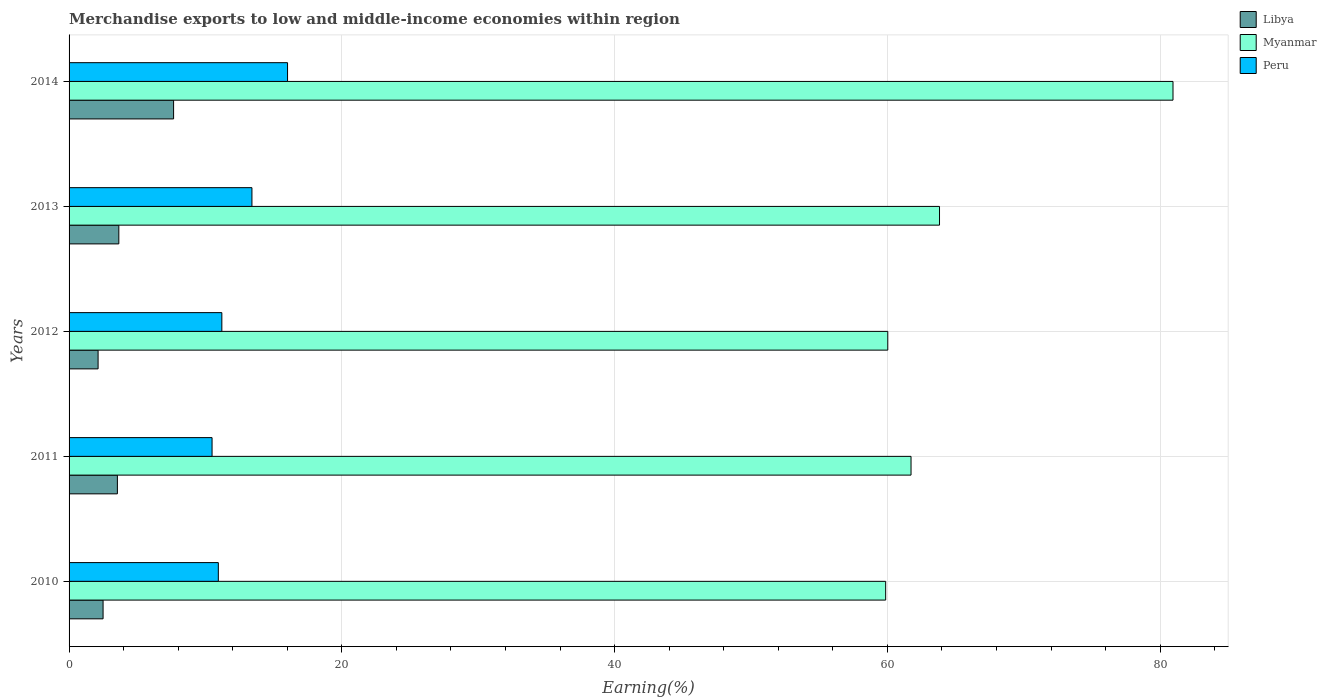How many different coloured bars are there?
Offer a very short reply. 3. How many groups of bars are there?
Offer a very short reply. 5. How many bars are there on the 3rd tick from the top?
Offer a very short reply. 3. How many bars are there on the 1st tick from the bottom?
Offer a very short reply. 3. What is the label of the 4th group of bars from the top?
Your answer should be very brief. 2011. In how many cases, is the number of bars for a given year not equal to the number of legend labels?
Your answer should be very brief. 0. What is the percentage of amount earned from merchandise exports in Libya in 2011?
Make the answer very short. 3.54. Across all years, what is the maximum percentage of amount earned from merchandise exports in Myanmar?
Make the answer very short. 80.94. Across all years, what is the minimum percentage of amount earned from merchandise exports in Peru?
Provide a succinct answer. 10.48. What is the total percentage of amount earned from merchandise exports in Peru in the graph?
Your answer should be compact. 62.06. What is the difference between the percentage of amount earned from merchandise exports in Libya in 2013 and that in 2014?
Offer a terse response. -4.02. What is the difference between the percentage of amount earned from merchandise exports in Myanmar in 2011 and the percentage of amount earned from merchandise exports in Libya in 2014?
Your response must be concise. 54.07. What is the average percentage of amount earned from merchandise exports in Libya per year?
Provide a succinct answer. 3.9. In the year 2012, what is the difference between the percentage of amount earned from merchandise exports in Libya and percentage of amount earned from merchandise exports in Peru?
Provide a succinct answer. -9.07. What is the ratio of the percentage of amount earned from merchandise exports in Libya in 2013 to that in 2014?
Make the answer very short. 0.48. Is the percentage of amount earned from merchandise exports in Libya in 2012 less than that in 2014?
Keep it short and to the point. Yes. Is the difference between the percentage of amount earned from merchandise exports in Libya in 2010 and 2014 greater than the difference between the percentage of amount earned from merchandise exports in Peru in 2010 and 2014?
Ensure brevity in your answer.  No. What is the difference between the highest and the second highest percentage of amount earned from merchandise exports in Peru?
Ensure brevity in your answer.  2.61. What is the difference between the highest and the lowest percentage of amount earned from merchandise exports in Peru?
Offer a terse response. 5.53. What does the 1st bar from the bottom in 2011 represents?
Ensure brevity in your answer.  Libya. How many bars are there?
Give a very brief answer. 15. How many years are there in the graph?
Your answer should be compact. 5. What is the difference between two consecutive major ticks on the X-axis?
Your response must be concise. 20. Are the values on the major ticks of X-axis written in scientific E-notation?
Your answer should be very brief. No. Where does the legend appear in the graph?
Ensure brevity in your answer.  Top right. What is the title of the graph?
Offer a very short reply. Merchandise exports to low and middle-income economies within region. What is the label or title of the X-axis?
Your answer should be compact. Earning(%). What is the Earning(%) in Libya in 2010?
Give a very brief answer. 2.49. What is the Earning(%) of Myanmar in 2010?
Provide a succinct answer. 59.88. What is the Earning(%) in Peru in 2010?
Make the answer very short. 10.94. What is the Earning(%) of Libya in 2011?
Your answer should be compact. 3.54. What is the Earning(%) in Myanmar in 2011?
Keep it short and to the point. 61.73. What is the Earning(%) in Peru in 2011?
Offer a terse response. 10.48. What is the Earning(%) of Libya in 2012?
Your answer should be very brief. 2.13. What is the Earning(%) of Myanmar in 2012?
Provide a short and direct response. 60.03. What is the Earning(%) of Peru in 2012?
Provide a succinct answer. 11.2. What is the Earning(%) in Libya in 2013?
Make the answer very short. 3.65. What is the Earning(%) in Myanmar in 2013?
Give a very brief answer. 63.82. What is the Earning(%) of Peru in 2013?
Provide a short and direct response. 13.41. What is the Earning(%) in Libya in 2014?
Your answer should be compact. 7.66. What is the Earning(%) of Myanmar in 2014?
Provide a short and direct response. 80.94. What is the Earning(%) of Peru in 2014?
Offer a very short reply. 16.02. Across all years, what is the maximum Earning(%) of Libya?
Your answer should be compact. 7.66. Across all years, what is the maximum Earning(%) in Myanmar?
Offer a very short reply. 80.94. Across all years, what is the maximum Earning(%) of Peru?
Provide a succinct answer. 16.02. Across all years, what is the minimum Earning(%) in Libya?
Keep it short and to the point. 2.13. Across all years, what is the minimum Earning(%) in Myanmar?
Make the answer very short. 59.88. Across all years, what is the minimum Earning(%) in Peru?
Your answer should be compact. 10.48. What is the total Earning(%) in Libya in the graph?
Make the answer very short. 19.48. What is the total Earning(%) of Myanmar in the graph?
Offer a very short reply. 326.41. What is the total Earning(%) of Peru in the graph?
Provide a short and direct response. 62.06. What is the difference between the Earning(%) of Libya in 2010 and that in 2011?
Offer a terse response. -1.05. What is the difference between the Earning(%) in Myanmar in 2010 and that in 2011?
Make the answer very short. -1.86. What is the difference between the Earning(%) of Peru in 2010 and that in 2011?
Give a very brief answer. 0.46. What is the difference between the Earning(%) of Libya in 2010 and that in 2012?
Offer a very short reply. 0.37. What is the difference between the Earning(%) of Myanmar in 2010 and that in 2012?
Provide a succinct answer. -0.15. What is the difference between the Earning(%) of Peru in 2010 and that in 2012?
Offer a very short reply. -0.26. What is the difference between the Earning(%) of Libya in 2010 and that in 2013?
Your answer should be compact. -1.15. What is the difference between the Earning(%) of Myanmar in 2010 and that in 2013?
Give a very brief answer. -3.95. What is the difference between the Earning(%) of Peru in 2010 and that in 2013?
Provide a short and direct response. -2.46. What is the difference between the Earning(%) of Libya in 2010 and that in 2014?
Your answer should be compact. -5.17. What is the difference between the Earning(%) in Myanmar in 2010 and that in 2014?
Ensure brevity in your answer.  -21.07. What is the difference between the Earning(%) in Peru in 2010 and that in 2014?
Provide a short and direct response. -5.07. What is the difference between the Earning(%) in Libya in 2011 and that in 2012?
Provide a succinct answer. 1.42. What is the difference between the Earning(%) in Myanmar in 2011 and that in 2012?
Keep it short and to the point. 1.7. What is the difference between the Earning(%) in Peru in 2011 and that in 2012?
Provide a succinct answer. -0.72. What is the difference between the Earning(%) of Libya in 2011 and that in 2013?
Offer a terse response. -0.1. What is the difference between the Earning(%) in Myanmar in 2011 and that in 2013?
Provide a short and direct response. -2.09. What is the difference between the Earning(%) in Peru in 2011 and that in 2013?
Keep it short and to the point. -2.92. What is the difference between the Earning(%) of Libya in 2011 and that in 2014?
Your answer should be very brief. -4.12. What is the difference between the Earning(%) of Myanmar in 2011 and that in 2014?
Offer a very short reply. -19.21. What is the difference between the Earning(%) in Peru in 2011 and that in 2014?
Provide a succinct answer. -5.53. What is the difference between the Earning(%) of Libya in 2012 and that in 2013?
Offer a very short reply. -1.52. What is the difference between the Earning(%) in Myanmar in 2012 and that in 2013?
Your answer should be very brief. -3.79. What is the difference between the Earning(%) in Peru in 2012 and that in 2013?
Give a very brief answer. -2.21. What is the difference between the Earning(%) in Libya in 2012 and that in 2014?
Provide a short and direct response. -5.54. What is the difference between the Earning(%) of Myanmar in 2012 and that in 2014?
Your answer should be very brief. -20.91. What is the difference between the Earning(%) of Peru in 2012 and that in 2014?
Provide a succinct answer. -4.82. What is the difference between the Earning(%) of Libya in 2013 and that in 2014?
Make the answer very short. -4.02. What is the difference between the Earning(%) in Myanmar in 2013 and that in 2014?
Keep it short and to the point. -17.12. What is the difference between the Earning(%) in Peru in 2013 and that in 2014?
Offer a terse response. -2.61. What is the difference between the Earning(%) in Libya in 2010 and the Earning(%) in Myanmar in 2011?
Your answer should be compact. -59.24. What is the difference between the Earning(%) in Libya in 2010 and the Earning(%) in Peru in 2011?
Provide a short and direct response. -7.99. What is the difference between the Earning(%) in Myanmar in 2010 and the Earning(%) in Peru in 2011?
Make the answer very short. 49.39. What is the difference between the Earning(%) of Libya in 2010 and the Earning(%) of Myanmar in 2012?
Your answer should be compact. -57.54. What is the difference between the Earning(%) of Libya in 2010 and the Earning(%) of Peru in 2012?
Provide a short and direct response. -8.71. What is the difference between the Earning(%) in Myanmar in 2010 and the Earning(%) in Peru in 2012?
Your response must be concise. 48.67. What is the difference between the Earning(%) of Libya in 2010 and the Earning(%) of Myanmar in 2013?
Your answer should be compact. -61.33. What is the difference between the Earning(%) of Libya in 2010 and the Earning(%) of Peru in 2013?
Ensure brevity in your answer.  -10.91. What is the difference between the Earning(%) in Myanmar in 2010 and the Earning(%) in Peru in 2013?
Offer a very short reply. 46.47. What is the difference between the Earning(%) of Libya in 2010 and the Earning(%) of Myanmar in 2014?
Provide a short and direct response. -78.45. What is the difference between the Earning(%) of Libya in 2010 and the Earning(%) of Peru in 2014?
Offer a terse response. -13.53. What is the difference between the Earning(%) in Myanmar in 2010 and the Earning(%) in Peru in 2014?
Keep it short and to the point. 43.86. What is the difference between the Earning(%) of Libya in 2011 and the Earning(%) of Myanmar in 2012?
Your response must be concise. -56.49. What is the difference between the Earning(%) in Libya in 2011 and the Earning(%) in Peru in 2012?
Give a very brief answer. -7.66. What is the difference between the Earning(%) of Myanmar in 2011 and the Earning(%) of Peru in 2012?
Offer a terse response. 50.53. What is the difference between the Earning(%) of Libya in 2011 and the Earning(%) of Myanmar in 2013?
Ensure brevity in your answer.  -60.28. What is the difference between the Earning(%) in Libya in 2011 and the Earning(%) in Peru in 2013?
Your answer should be very brief. -9.86. What is the difference between the Earning(%) of Myanmar in 2011 and the Earning(%) of Peru in 2013?
Offer a terse response. 48.33. What is the difference between the Earning(%) in Libya in 2011 and the Earning(%) in Myanmar in 2014?
Make the answer very short. -77.4. What is the difference between the Earning(%) in Libya in 2011 and the Earning(%) in Peru in 2014?
Give a very brief answer. -12.48. What is the difference between the Earning(%) in Myanmar in 2011 and the Earning(%) in Peru in 2014?
Offer a terse response. 45.72. What is the difference between the Earning(%) of Libya in 2012 and the Earning(%) of Myanmar in 2013?
Provide a short and direct response. -61.7. What is the difference between the Earning(%) in Libya in 2012 and the Earning(%) in Peru in 2013?
Your answer should be very brief. -11.28. What is the difference between the Earning(%) in Myanmar in 2012 and the Earning(%) in Peru in 2013?
Offer a very short reply. 46.62. What is the difference between the Earning(%) in Libya in 2012 and the Earning(%) in Myanmar in 2014?
Keep it short and to the point. -78.82. What is the difference between the Earning(%) in Libya in 2012 and the Earning(%) in Peru in 2014?
Make the answer very short. -13.89. What is the difference between the Earning(%) in Myanmar in 2012 and the Earning(%) in Peru in 2014?
Keep it short and to the point. 44.01. What is the difference between the Earning(%) in Libya in 2013 and the Earning(%) in Myanmar in 2014?
Provide a short and direct response. -77.3. What is the difference between the Earning(%) in Libya in 2013 and the Earning(%) in Peru in 2014?
Keep it short and to the point. -12.37. What is the difference between the Earning(%) of Myanmar in 2013 and the Earning(%) of Peru in 2014?
Your response must be concise. 47.8. What is the average Earning(%) in Libya per year?
Your response must be concise. 3.9. What is the average Earning(%) in Myanmar per year?
Offer a very short reply. 65.28. What is the average Earning(%) of Peru per year?
Make the answer very short. 12.41. In the year 2010, what is the difference between the Earning(%) in Libya and Earning(%) in Myanmar?
Offer a terse response. -57.38. In the year 2010, what is the difference between the Earning(%) of Libya and Earning(%) of Peru?
Provide a short and direct response. -8.45. In the year 2010, what is the difference between the Earning(%) in Myanmar and Earning(%) in Peru?
Keep it short and to the point. 48.93. In the year 2011, what is the difference between the Earning(%) of Libya and Earning(%) of Myanmar?
Your response must be concise. -58.19. In the year 2011, what is the difference between the Earning(%) of Libya and Earning(%) of Peru?
Your answer should be very brief. -6.94. In the year 2011, what is the difference between the Earning(%) of Myanmar and Earning(%) of Peru?
Your response must be concise. 51.25. In the year 2012, what is the difference between the Earning(%) in Libya and Earning(%) in Myanmar?
Your answer should be compact. -57.9. In the year 2012, what is the difference between the Earning(%) in Libya and Earning(%) in Peru?
Your response must be concise. -9.07. In the year 2012, what is the difference between the Earning(%) of Myanmar and Earning(%) of Peru?
Ensure brevity in your answer.  48.83. In the year 2013, what is the difference between the Earning(%) of Libya and Earning(%) of Myanmar?
Keep it short and to the point. -60.18. In the year 2013, what is the difference between the Earning(%) in Libya and Earning(%) in Peru?
Keep it short and to the point. -9.76. In the year 2013, what is the difference between the Earning(%) of Myanmar and Earning(%) of Peru?
Offer a very short reply. 50.42. In the year 2014, what is the difference between the Earning(%) in Libya and Earning(%) in Myanmar?
Offer a very short reply. -73.28. In the year 2014, what is the difference between the Earning(%) in Libya and Earning(%) in Peru?
Offer a very short reply. -8.36. In the year 2014, what is the difference between the Earning(%) in Myanmar and Earning(%) in Peru?
Offer a terse response. 64.92. What is the ratio of the Earning(%) of Libya in 2010 to that in 2011?
Keep it short and to the point. 0.7. What is the ratio of the Earning(%) in Myanmar in 2010 to that in 2011?
Give a very brief answer. 0.97. What is the ratio of the Earning(%) in Peru in 2010 to that in 2011?
Make the answer very short. 1.04. What is the ratio of the Earning(%) in Libya in 2010 to that in 2012?
Make the answer very short. 1.17. What is the ratio of the Earning(%) of Myanmar in 2010 to that in 2012?
Make the answer very short. 1. What is the ratio of the Earning(%) of Peru in 2010 to that in 2012?
Offer a very short reply. 0.98. What is the ratio of the Earning(%) of Libya in 2010 to that in 2013?
Make the answer very short. 0.68. What is the ratio of the Earning(%) of Myanmar in 2010 to that in 2013?
Make the answer very short. 0.94. What is the ratio of the Earning(%) of Peru in 2010 to that in 2013?
Your answer should be compact. 0.82. What is the ratio of the Earning(%) of Libya in 2010 to that in 2014?
Keep it short and to the point. 0.33. What is the ratio of the Earning(%) in Myanmar in 2010 to that in 2014?
Provide a short and direct response. 0.74. What is the ratio of the Earning(%) in Peru in 2010 to that in 2014?
Ensure brevity in your answer.  0.68. What is the ratio of the Earning(%) of Libya in 2011 to that in 2012?
Provide a short and direct response. 1.67. What is the ratio of the Earning(%) of Myanmar in 2011 to that in 2012?
Give a very brief answer. 1.03. What is the ratio of the Earning(%) in Peru in 2011 to that in 2012?
Ensure brevity in your answer.  0.94. What is the ratio of the Earning(%) of Libya in 2011 to that in 2013?
Offer a very short reply. 0.97. What is the ratio of the Earning(%) of Myanmar in 2011 to that in 2013?
Your response must be concise. 0.97. What is the ratio of the Earning(%) in Peru in 2011 to that in 2013?
Make the answer very short. 0.78. What is the ratio of the Earning(%) of Libya in 2011 to that in 2014?
Your response must be concise. 0.46. What is the ratio of the Earning(%) in Myanmar in 2011 to that in 2014?
Make the answer very short. 0.76. What is the ratio of the Earning(%) in Peru in 2011 to that in 2014?
Your response must be concise. 0.65. What is the ratio of the Earning(%) in Libya in 2012 to that in 2013?
Offer a terse response. 0.58. What is the ratio of the Earning(%) in Myanmar in 2012 to that in 2013?
Give a very brief answer. 0.94. What is the ratio of the Earning(%) in Peru in 2012 to that in 2013?
Provide a succinct answer. 0.84. What is the ratio of the Earning(%) in Libya in 2012 to that in 2014?
Provide a succinct answer. 0.28. What is the ratio of the Earning(%) of Myanmar in 2012 to that in 2014?
Ensure brevity in your answer.  0.74. What is the ratio of the Earning(%) of Peru in 2012 to that in 2014?
Your answer should be compact. 0.7. What is the ratio of the Earning(%) in Libya in 2013 to that in 2014?
Your answer should be very brief. 0.48. What is the ratio of the Earning(%) in Myanmar in 2013 to that in 2014?
Make the answer very short. 0.79. What is the ratio of the Earning(%) in Peru in 2013 to that in 2014?
Offer a terse response. 0.84. What is the difference between the highest and the second highest Earning(%) of Libya?
Ensure brevity in your answer.  4.02. What is the difference between the highest and the second highest Earning(%) in Myanmar?
Provide a short and direct response. 17.12. What is the difference between the highest and the second highest Earning(%) in Peru?
Make the answer very short. 2.61. What is the difference between the highest and the lowest Earning(%) in Libya?
Ensure brevity in your answer.  5.54. What is the difference between the highest and the lowest Earning(%) of Myanmar?
Make the answer very short. 21.07. What is the difference between the highest and the lowest Earning(%) of Peru?
Ensure brevity in your answer.  5.53. 